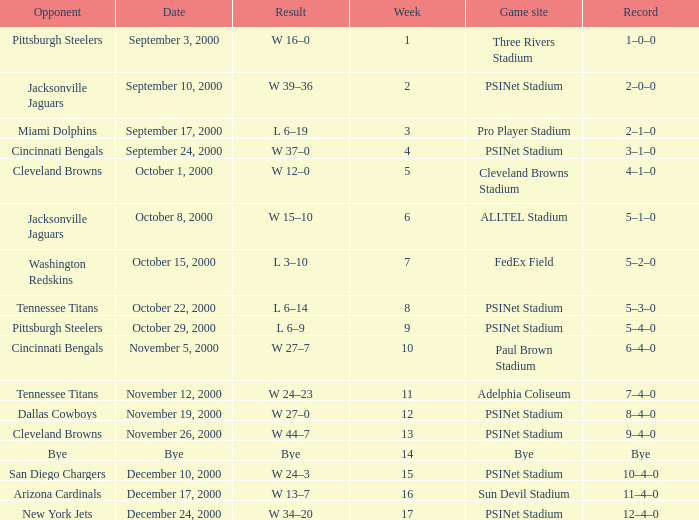What's the record for October 8, 2000 before week 13? 5–1–0. 